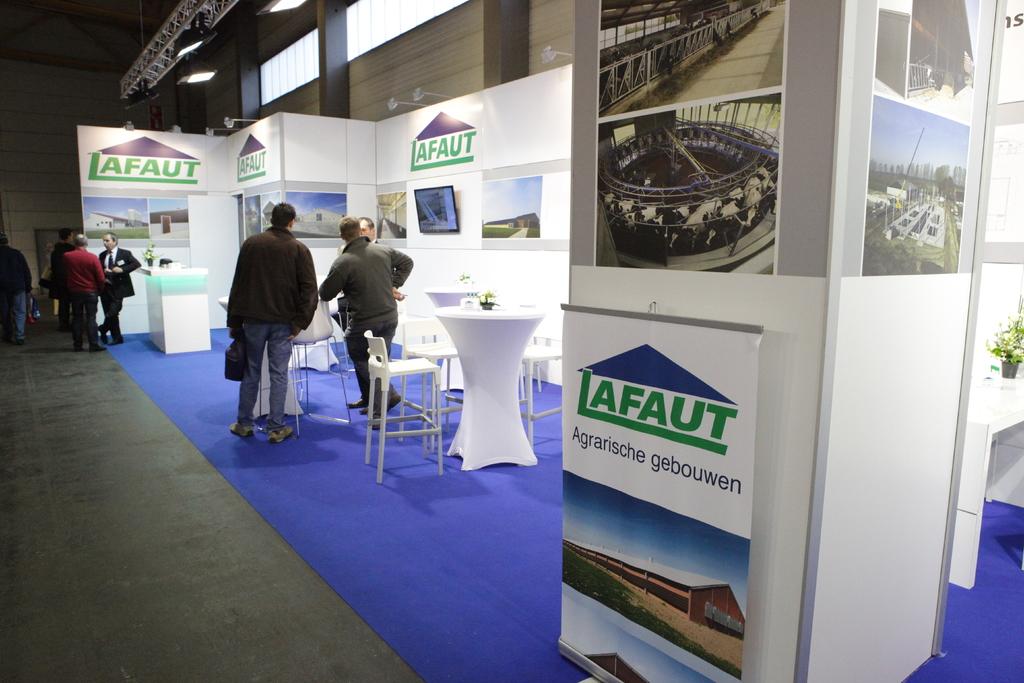What brand is this stall for?
Offer a very short reply. Lafaut. 